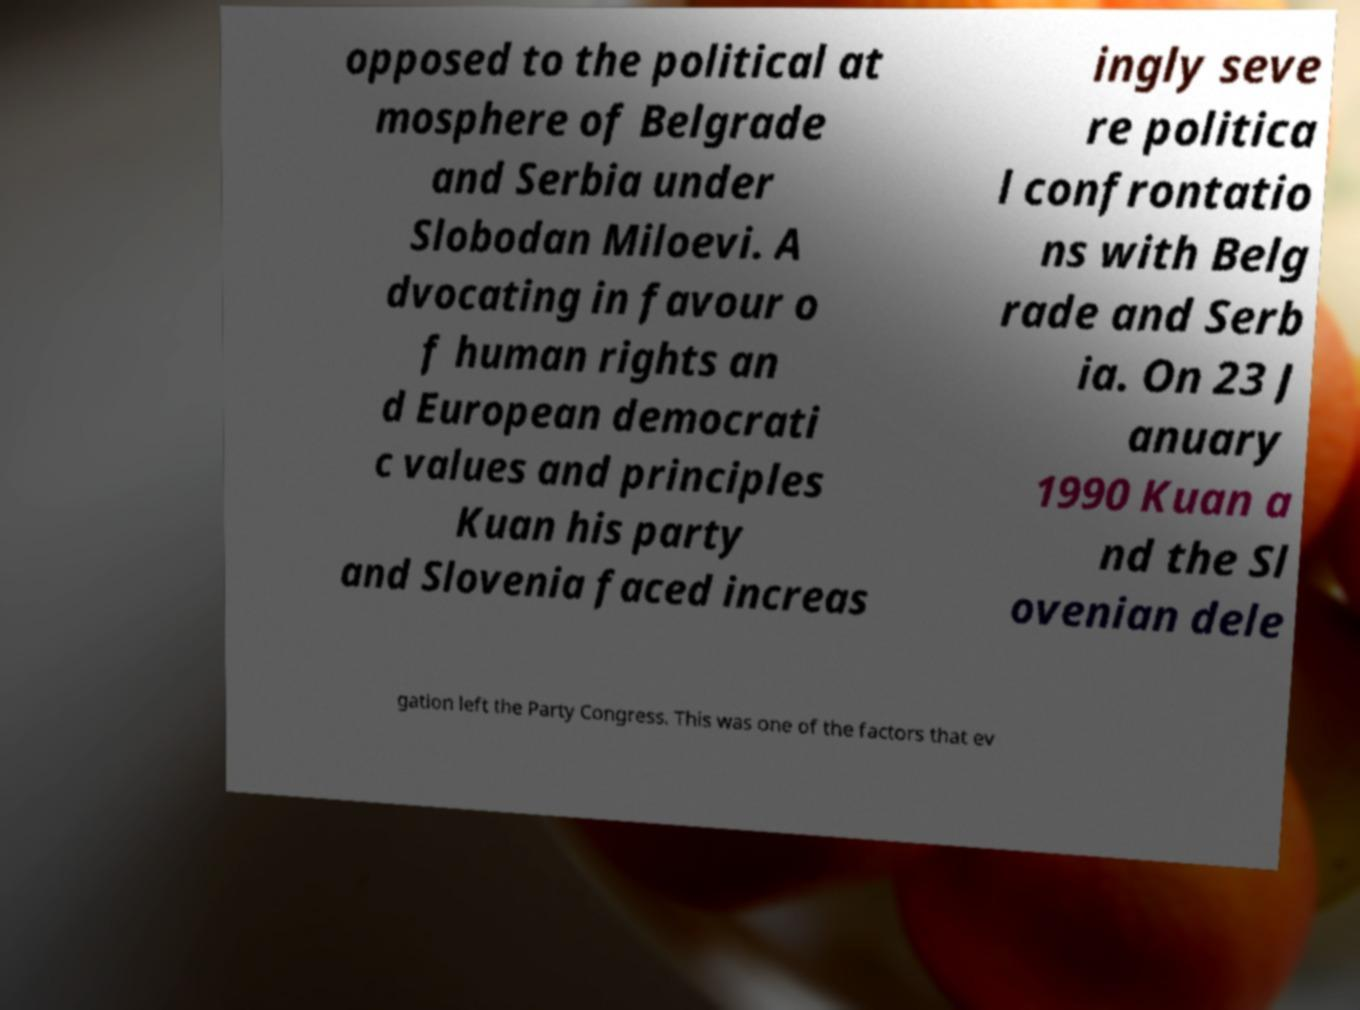Can you read and provide the text displayed in the image?This photo seems to have some interesting text. Can you extract and type it out for me? opposed to the political at mosphere of Belgrade and Serbia under Slobodan Miloevi. A dvocating in favour o f human rights an d European democrati c values and principles Kuan his party and Slovenia faced increas ingly seve re politica l confrontatio ns with Belg rade and Serb ia. On 23 J anuary 1990 Kuan a nd the Sl ovenian dele gation left the Party Congress. This was one of the factors that ev 